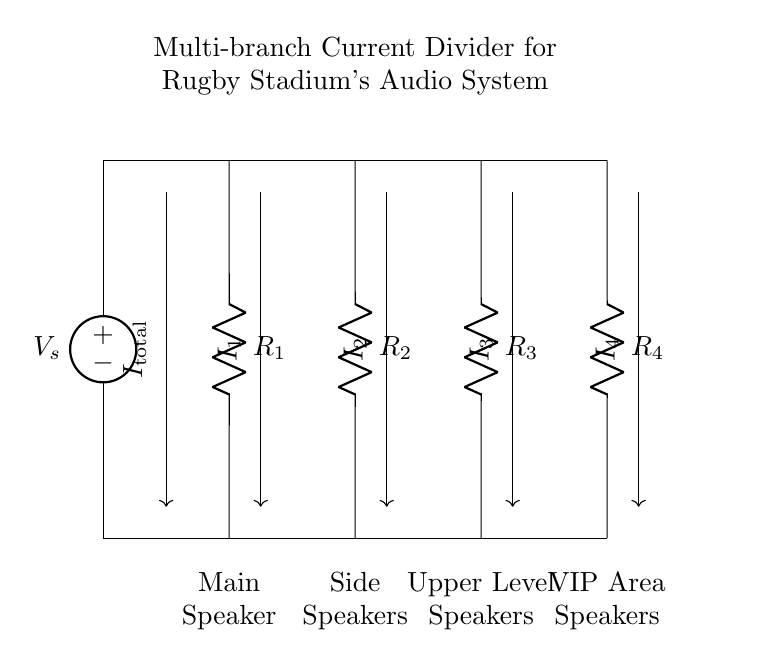What is the total current in the circuit? The total current is represented by the label I_total next to the current entering the circuit.
Answer: I_total How many resistors are in the circuit? There are four resistors indicated in the diagram, labeled R_1, R_2, R_3, and R_4.
Answer: Four What is the purpose of the current divider in this circuit? The current divider's purpose is to allocate the total current among multiple branches (speakers) based on their resistance values, ensuring that each speaker receives an appropriate share of power.
Answer: Allocate current Which speaker has a dedicated resistor with the least resistance? In this configuration, it is not specified in the circuit but if R_1, R_2, R_3, or R_4 values were given, you could identify the speaker corresponding to the smallest resistor as receiving the most current.
Answer: Not specified How does increasing the resistance of R_2 affect I_2? Increasing R_2 would decrease I_2 according to the current divider principle, as more resistance means less current flows through that branch when total current is constant.
Answer: Decrease What component type is primarily used for audio speakers in this circuit? The speakers are typically represented as resistors in such circuit diagrams, thus they focus on the resistive nature of the speakers in relation to current flow.
Answer: Resistors 